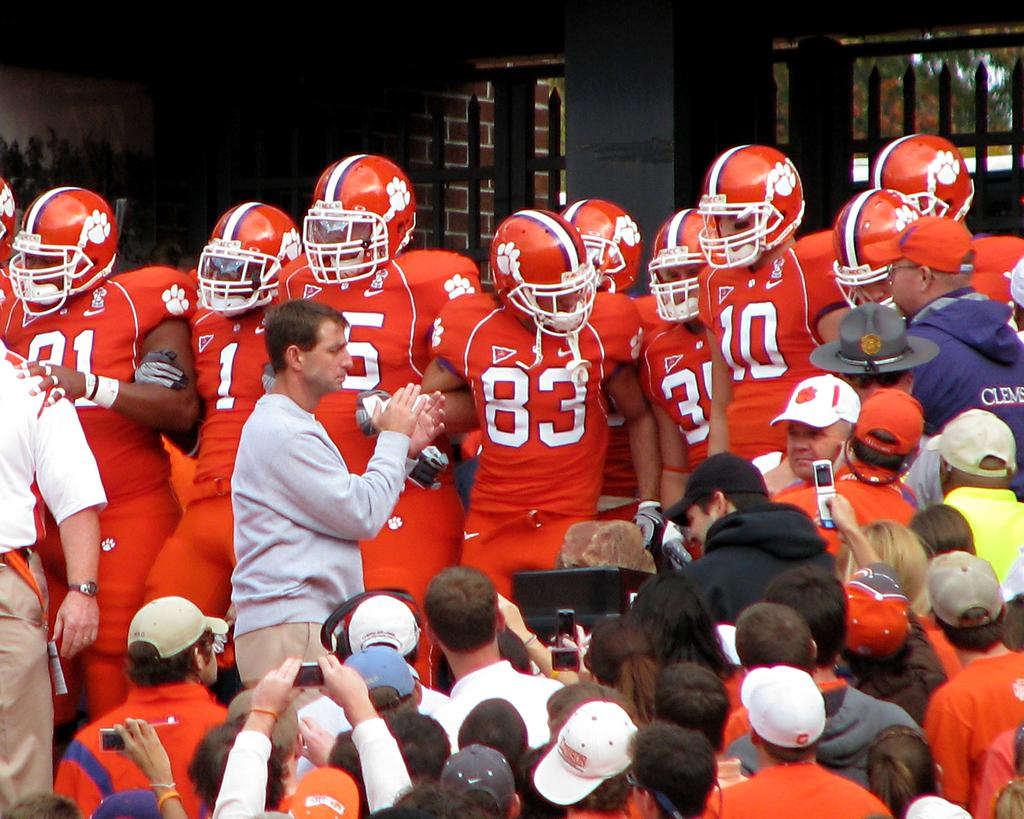How many persons can be seen in the image? There are persons in the image, but the exact number is not specified. What can be seen in the background of the image? In the background of the image, there is a wooden grill, buildings, trees, and the sky. Can you describe the setting of the image? The image appears to be set outdoors, with a wooden grill, trees, and buildings visible in the background. What type of reaction can be seen from the icicle in the image? There is no icicle present in the image, so it is not possible to observe any reaction from it. 